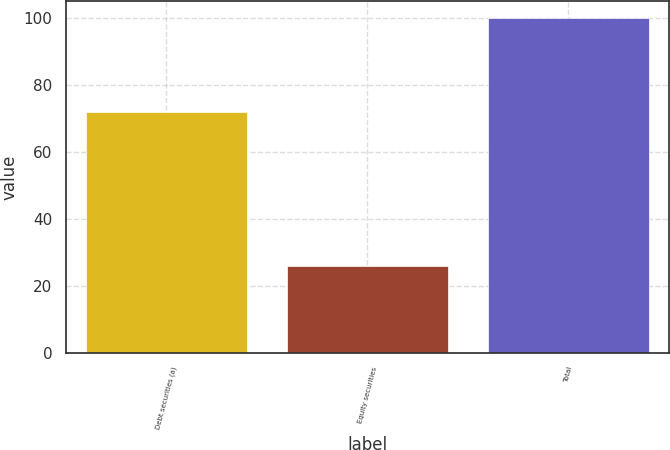<chart> <loc_0><loc_0><loc_500><loc_500><bar_chart><fcel>Debt securities (a)<fcel>Equity securities<fcel>Total<nl><fcel>72<fcel>26<fcel>100<nl></chart> 